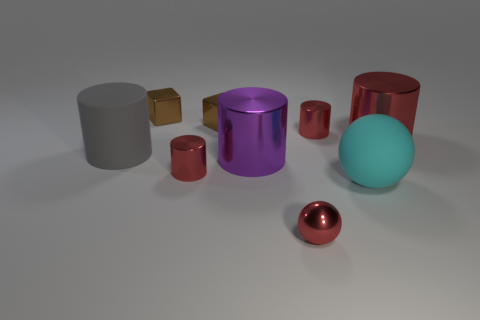Subtract all red cylinders. How many were subtracted if there are1red cylinders left? 2 Subtract all purple cylinders. How many cylinders are left? 4 Subtract all red cylinders. How many cylinders are left? 2 Subtract all cylinders. How many objects are left? 4 Subtract 4 cylinders. How many cylinders are left? 1 Subtract all red spheres. Subtract all yellow cubes. How many spheres are left? 1 Subtract all blue cylinders. How many cyan balls are left? 1 Subtract all objects. Subtract all big gray metal cylinders. How many objects are left? 0 Add 3 brown shiny blocks. How many brown shiny blocks are left? 5 Add 7 big purple metal blocks. How many big purple metal blocks exist? 7 